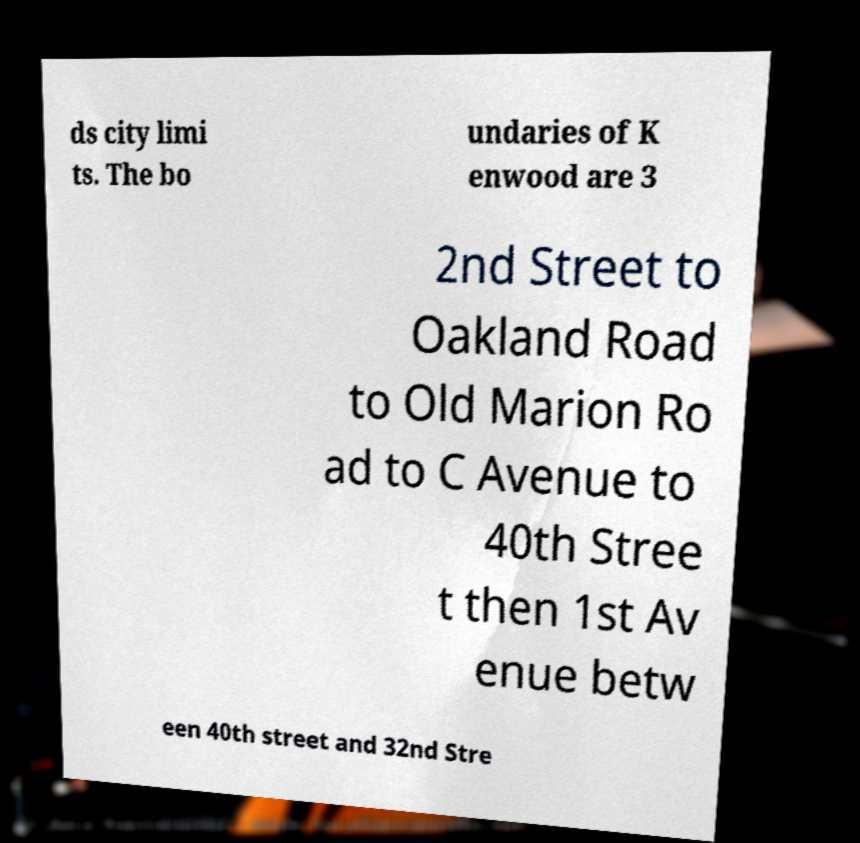Can you read and provide the text displayed in the image?This photo seems to have some interesting text. Can you extract and type it out for me? ds city limi ts. The bo undaries of K enwood are 3 2nd Street to Oakland Road to Old Marion Ro ad to C Avenue to 40th Stree t then 1st Av enue betw een 40th street and 32nd Stre 